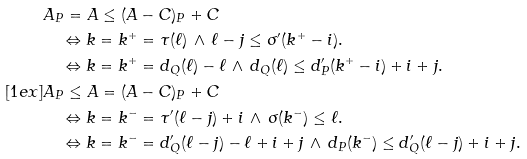Convert formula to latex. <formula><loc_0><loc_0><loc_500><loc_500>& A _ { P } = A \leq ( A - C ) _ { P } + C \\ & \quad \Leftrightarrow k = k ^ { + } = \tau ( \ell ) \, \wedge \, \ell - j \leq \sigma ^ { \prime } ( k ^ { + } - i ) . \\ & \quad \Leftrightarrow k = k ^ { + } = d _ { Q } ( \ell ) - \ell \, \wedge \, d _ { Q } ( \ell ) \leq d ^ { \prime } _ { P } ( k ^ { + } - i ) + i + j . \\ [ 1 e x ] & A _ { P } \leq A = ( A - C ) _ { P } + C \\ & \quad \Leftrightarrow k = k ^ { - } = \tau ^ { \prime } ( \ell - j ) + i \, \wedge \, \sigma ( k ^ { - } ) \leq \ell . \\ & \quad \Leftrightarrow k = k ^ { - } = d ^ { \prime } _ { Q } ( \ell - j ) - \ell + i + j \, \wedge \, d _ { P } ( k ^ { - } ) \leq d ^ { \prime } _ { Q } ( \ell - j ) + i + j .</formula> 